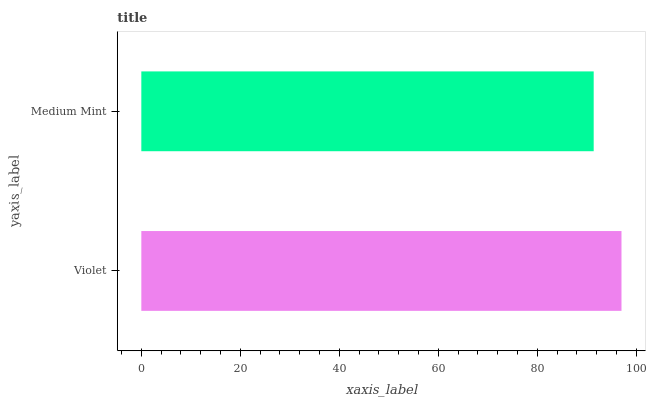Is Medium Mint the minimum?
Answer yes or no. Yes. Is Violet the maximum?
Answer yes or no. Yes. Is Medium Mint the maximum?
Answer yes or no. No. Is Violet greater than Medium Mint?
Answer yes or no. Yes. Is Medium Mint less than Violet?
Answer yes or no. Yes. Is Medium Mint greater than Violet?
Answer yes or no. No. Is Violet less than Medium Mint?
Answer yes or no. No. Is Violet the high median?
Answer yes or no. Yes. Is Medium Mint the low median?
Answer yes or no. Yes. Is Medium Mint the high median?
Answer yes or no. No. Is Violet the low median?
Answer yes or no. No. 